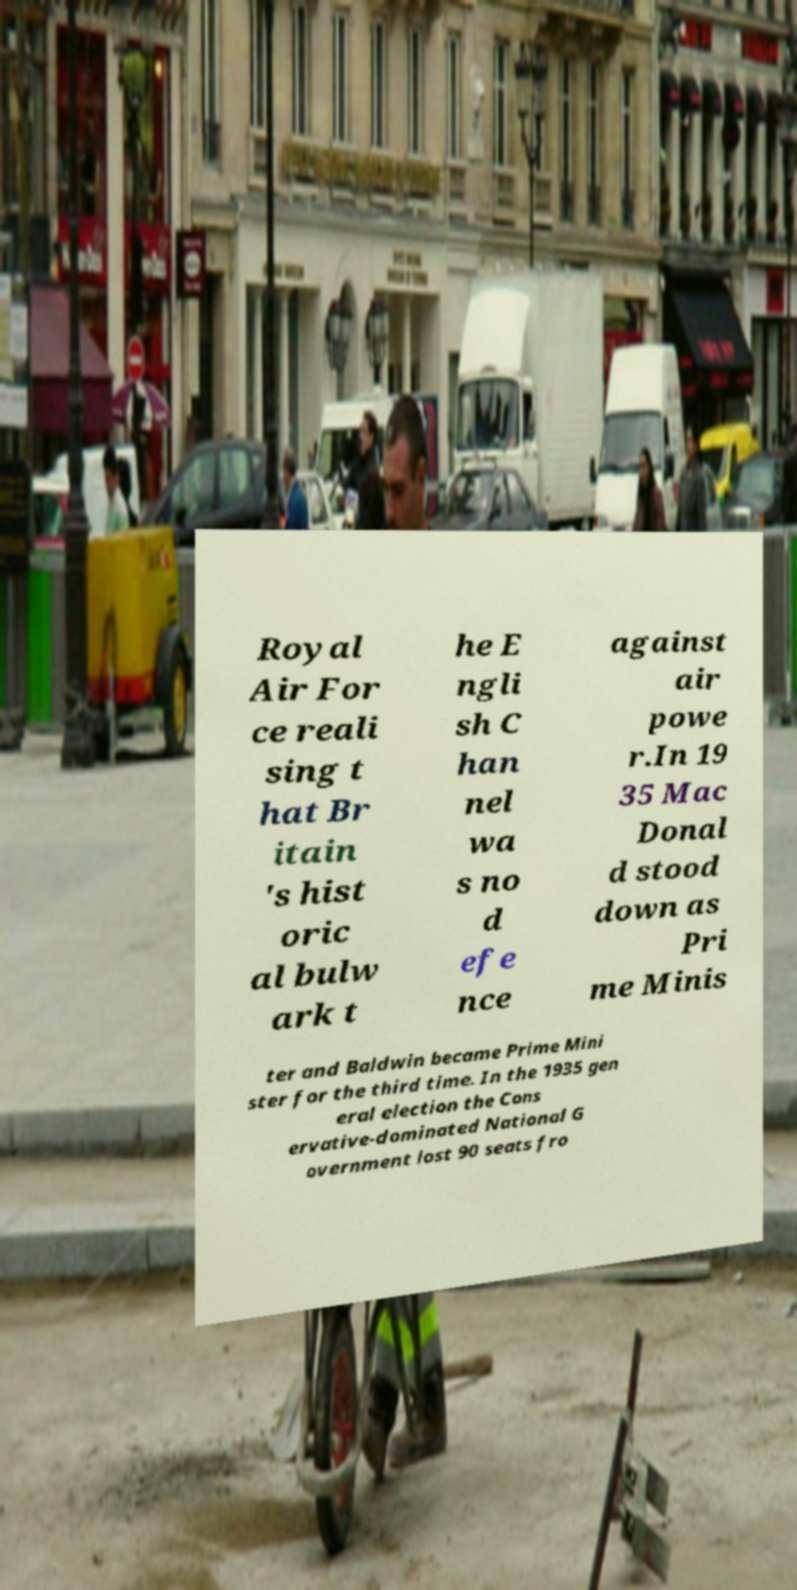Could you assist in decoding the text presented in this image and type it out clearly? Royal Air For ce reali sing t hat Br itain 's hist oric al bulw ark t he E ngli sh C han nel wa s no d efe nce against air powe r.In 19 35 Mac Donal d stood down as Pri me Minis ter and Baldwin became Prime Mini ster for the third time. In the 1935 gen eral election the Cons ervative-dominated National G overnment lost 90 seats fro 